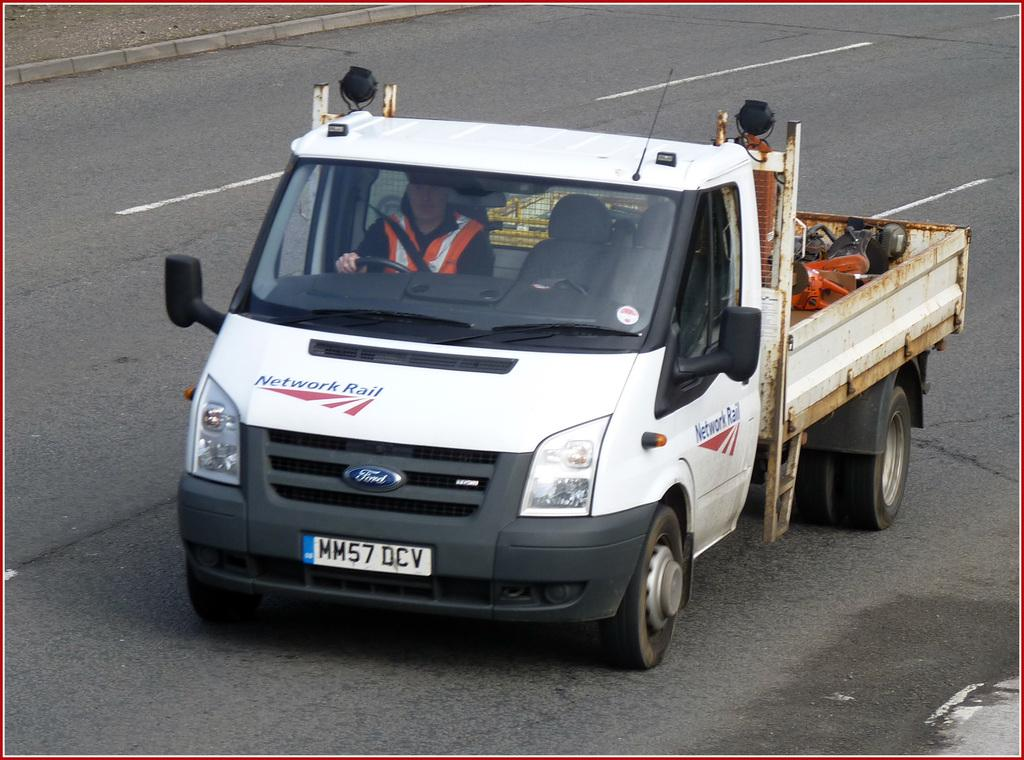What is the main subject of the image? There is a vehicle in the image. Where is the vehicle located? The vehicle is on the road. Is there anyone inside the vehicle? Yes, there is a man sitting in the vehicle. How many eggs are visible in the image? There are no eggs present in the image. Is the vehicle a fictional creation or based on reality? The vehicle is based on reality, as it is a common mode of transportation. 